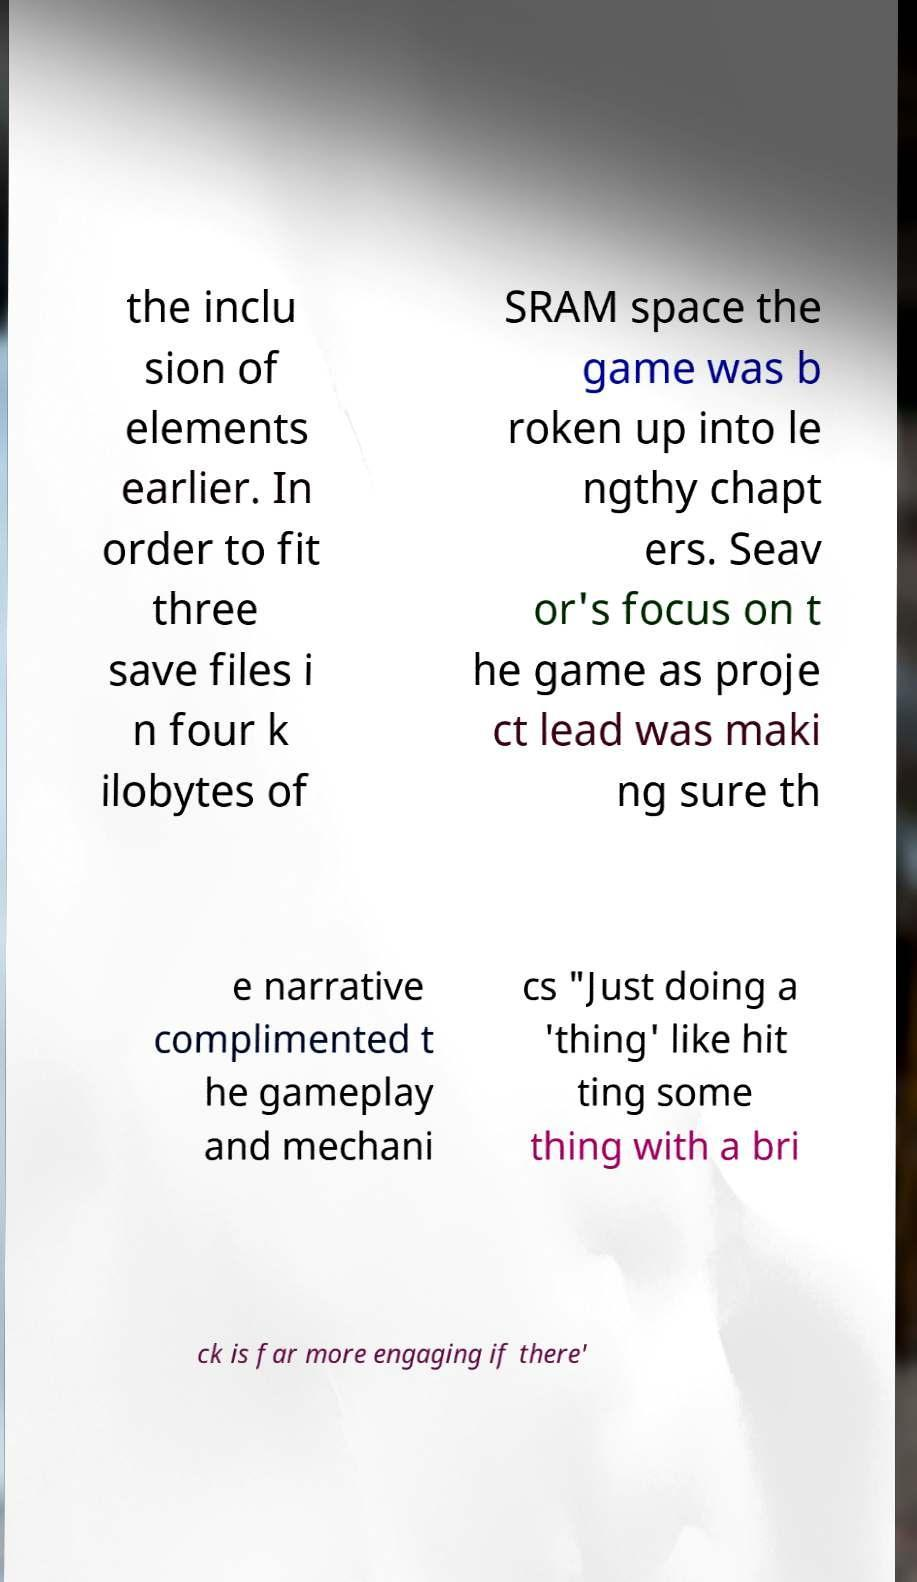I need the written content from this picture converted into text. Can you do that? the inclu sion of elements earlier. In order to fit three save files i n four k ilobytes of SRAM space the game was b roken up into le ngthy chapt ers. Seav or's focus on t he game as proje ct lead was maki ng sure th e narrative complimented t he gameplay and mechani cs "Just doing a 'thing' like hit ting some thing with a bri ck is far more engaging if there' 